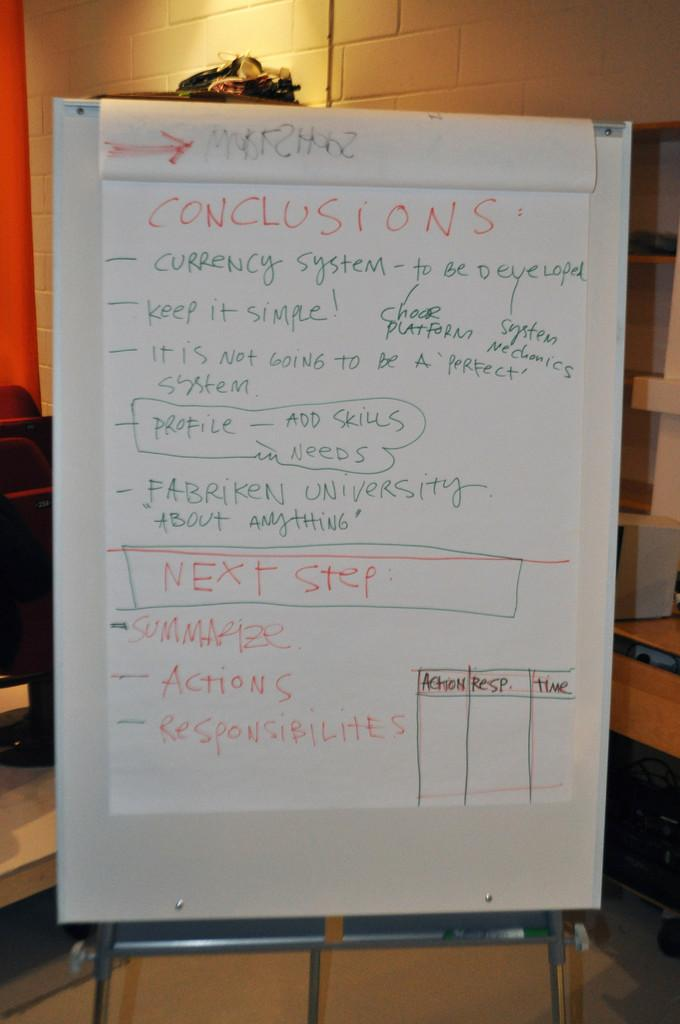<image>
Write a terse but informative summary of the picture. the word conclusions that is on some paper 